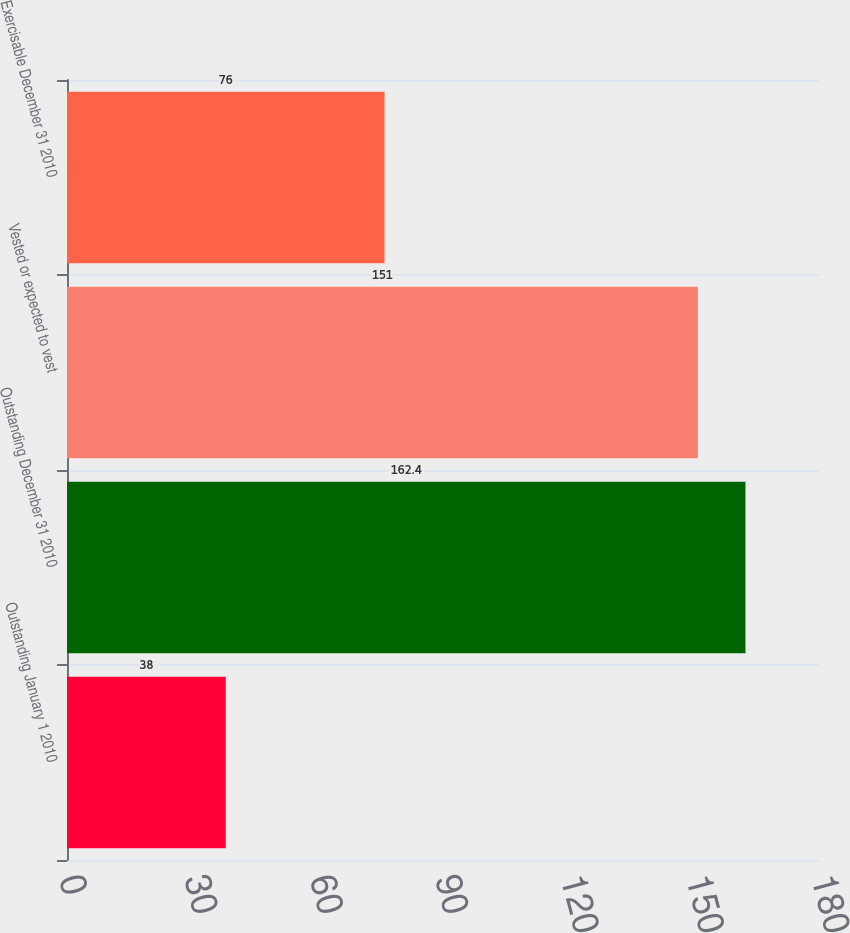<chart> <loc_0><loc_0><loc_500><loc_500><bar_chart><fcel>Outstanding January 1 2010<fcel>Outstanding December 31 2010<fcel>Vested or expected to vest<fcel>Exercisable December 31 2010<nl><fcel>38<fcel>162.4<fcel>151<fcel>76<nl></chart> 